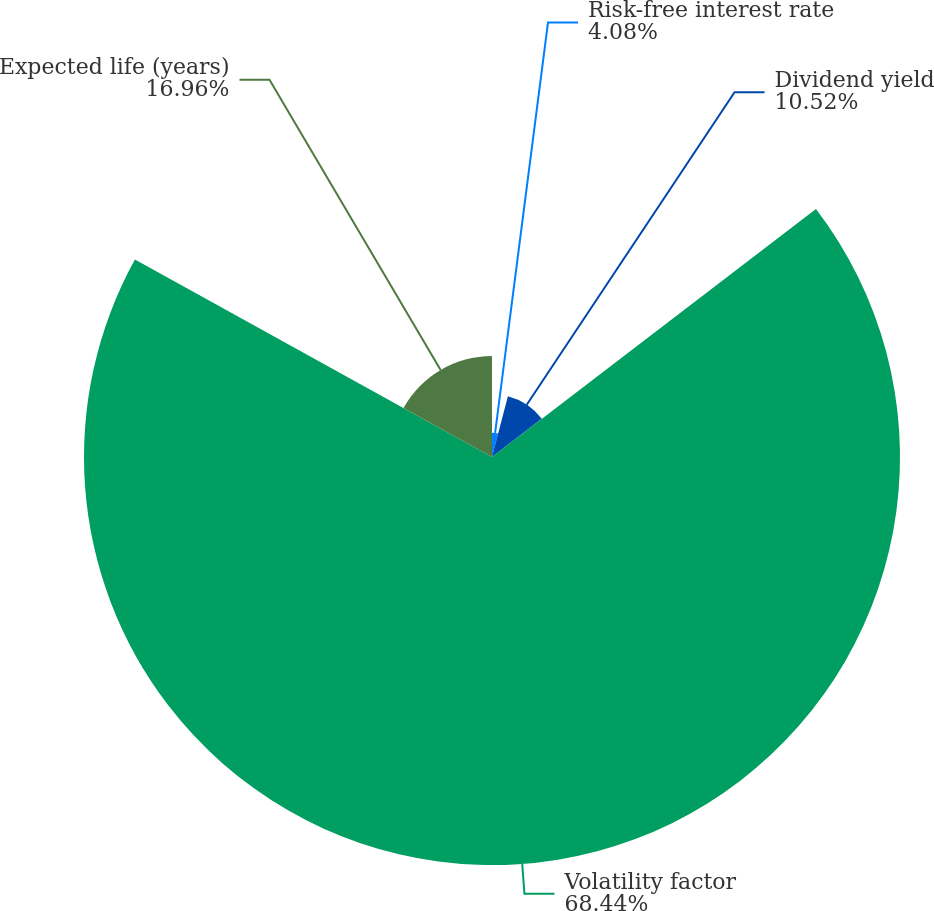Convert chart. <chart><loc_0><loc_0><loc_500><loc_500><pie_chart><fcel>Risk-free interest rate<fcel>Dividend yield<fcel>Volatility factor<fcel>Expected life (years)<nl><fcel>4.08%<fcel>10.52%<fcel>68.43%<fcel>16.96%<nl></chart> 